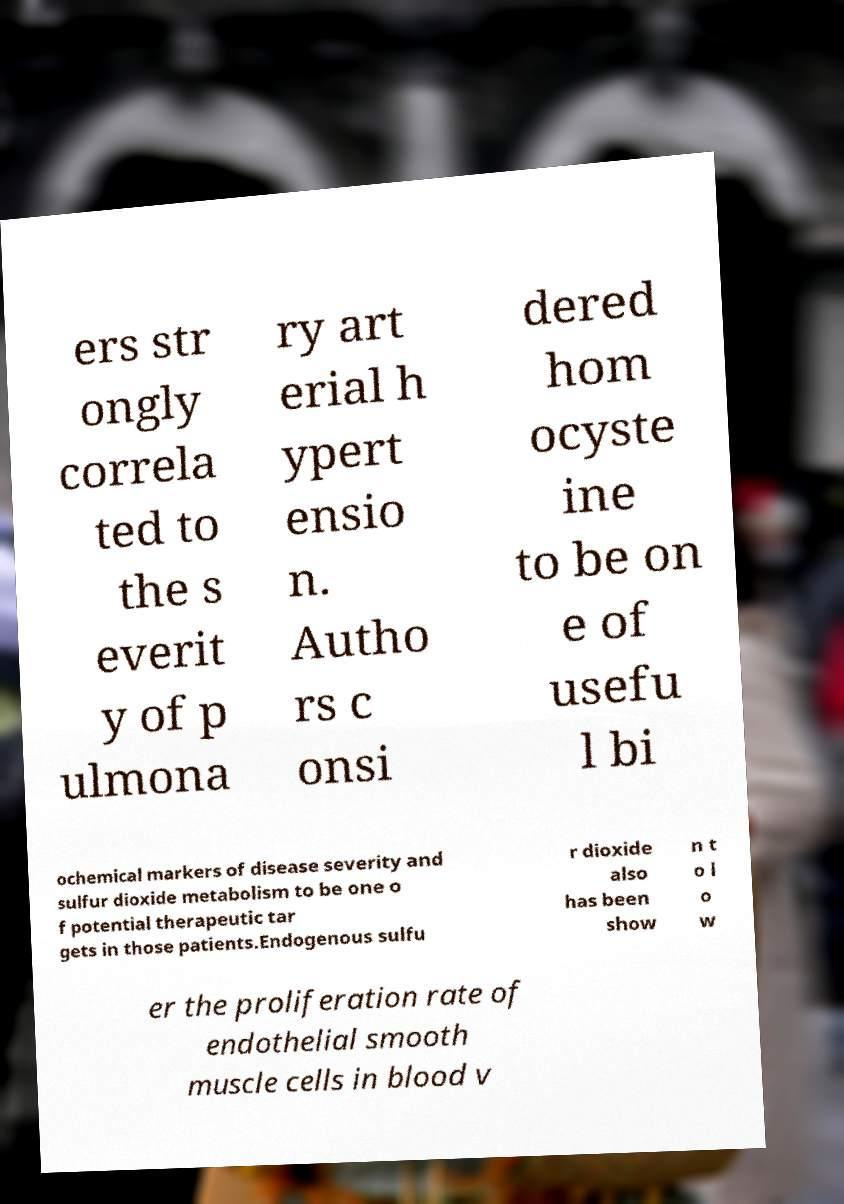What messages or text are displayed in this image? I need them in a readable, typed format. ers str ongly correla ted to the s everit y of p ulmona ry art erial h ypert ensio n. Autho rs c onsi dered hom ocyste ine to be on e of usefu l bi ochemical markers of disease severity and sulfur dioxide metabolism to be one o f potential therapeutic tar gets in those patients.Endogenous sulfu r dioxide also has been show n t o l o w er the proliferation rate of endothelial smooth muscle cells in blood v 